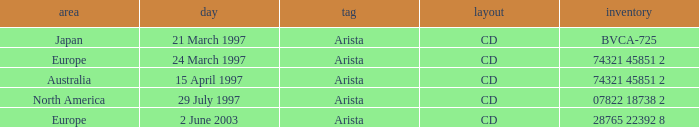What Format has the Region of Europe and a Catalog of 74321 45851 2? CD. 